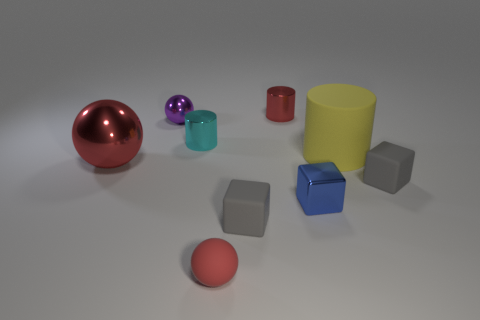There is a cylinder that is behind the yellow thing and in front of the small red cylinder; what is its material?
Offer a terse response. Metal. Is the color of the tiny matte ball the same as the shiny cylinder right of the tiny red rubber ball?
Offer a terse response. Yes. Do the cyan thing and the tiny red sphere have the same material?
Provide a succinct answer. No. What is the material of the red sphere that is the same size as the blue object?
Give a very brief answer. Rubber. How many objects are either shiny things that are on the left side of the tiny red shiny cylinder or red things?
Give a very brief answer. 5. Are there an equal number of gray matte blocks that are on the right side of the blue object and small purple spheres?
Ensure brevity in your answer.  Yes. Is the color of the matte sphere the same as the big shiny sphere?
Offer a very short reply. Yes. There is a small shiny thing that is both in front of the purple metal sphere and behind the large red sphere; what color is it?
Your response must be concise. Cyan. How many cylinders are blue objects or red things?
Make the answer very short. 1. Are there fewer large matte cylinders that are to the left of the big rubber cylinder than blue objects?
Ensure brevity in your answer.  Yes. 